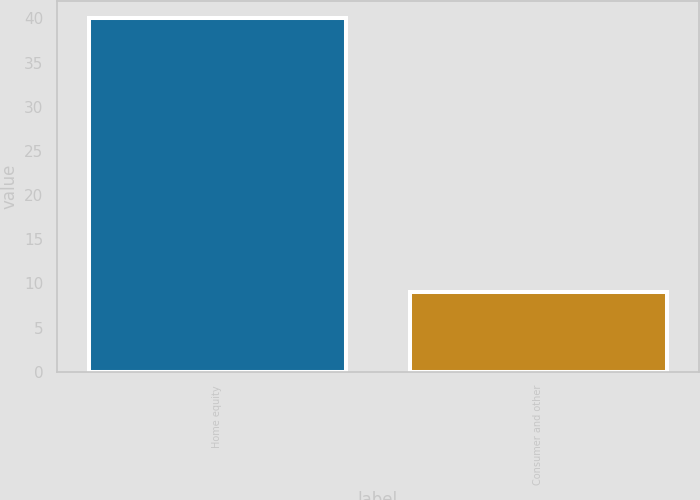Convert chart to OTSL. <chart><loc_0><loc_0><loc_500><loc_500><bar_chart><fcel>Home equity<fcel>Consumer and other<nl><fcel>40<fcel>9<nl></chart> 